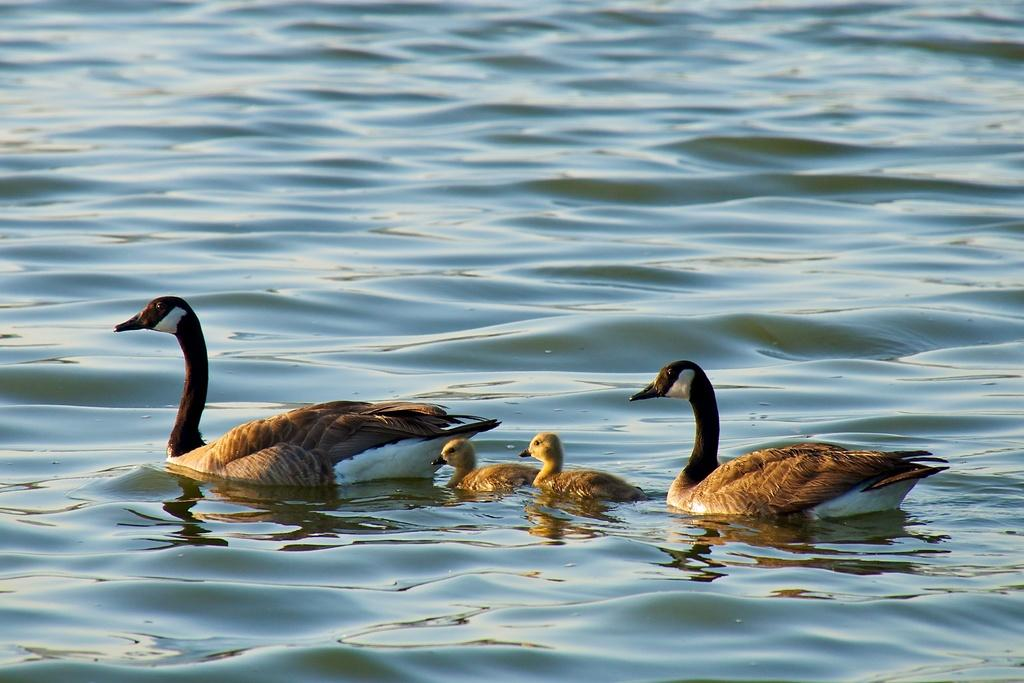What animals can be seen in the image? There are ducks in the image. Where are the ducks located? The ducks are in a water body. What type of humor can be observed in the duck's behavior in the image? There is no indication of humor or any specific behavior of the ducks in the image. 